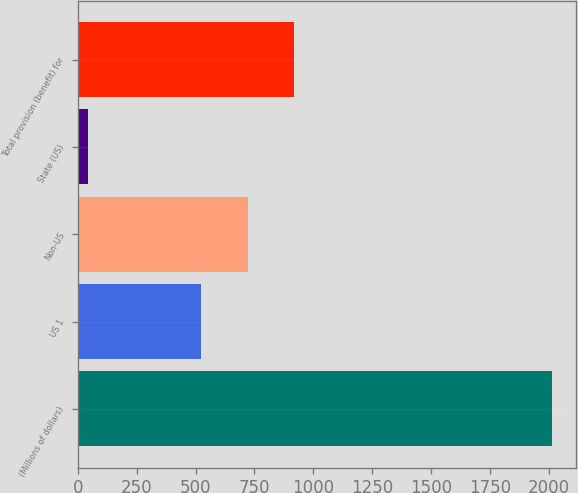<chart> <loc_0><loc_0><loc_500><loc_500><bar_chart><fcel>(Millions of dollars)<fcel>US 1<fcel>Non-US<fcel>State (US)<fcel>Total provision (benefit) for<nl><fcel>2015<fcel>525<fcel>722.3<fcel>42<fcel>919.6<nl></chart> 